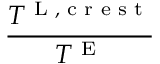<formula> <loc_0><loc_0><loc_500><loc_500>\frac { T ^ { L , c r e s t } } { T ^ { E } }</formula> 